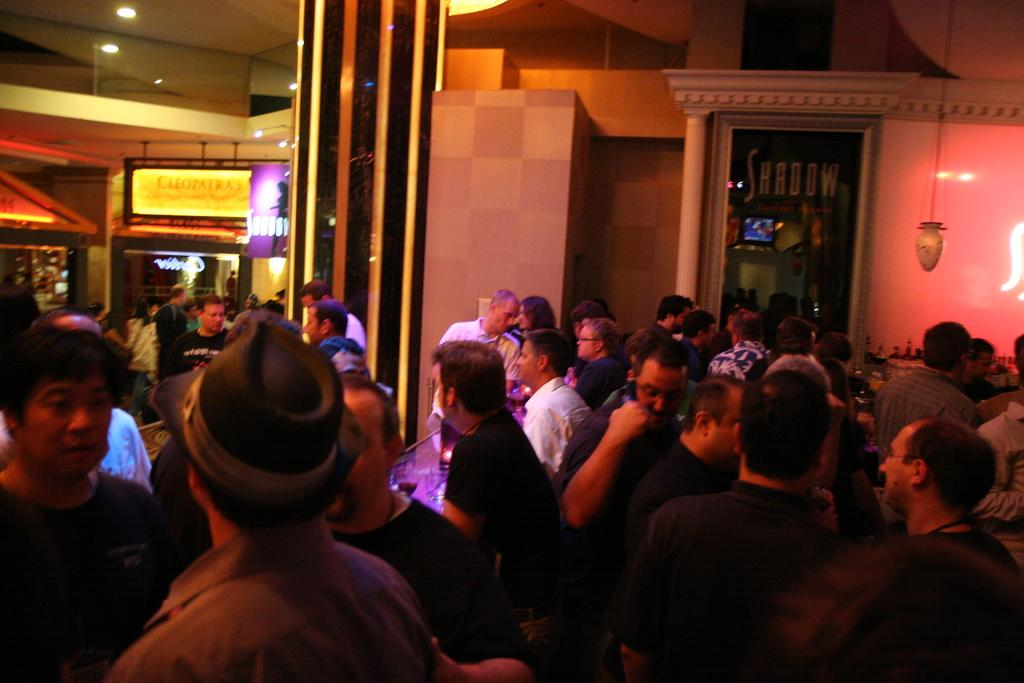How many people are in the image? There is a group of people in the image. What can be observed about the clothing of the people in the image? The people are wearing different color dresses. Can you describe any accessories worn by the people in the image? One person is wearing a hat. What can be seen in the background of the image? There are boards visible in the background, and there are lights attached to a wall. What type of quiver can be seen on the person wearing the hat in the image? There is no quiver present in the image. How does the zephyr affect the people in the image? There is no mention of a zephyr or any weather conditions in the image. 